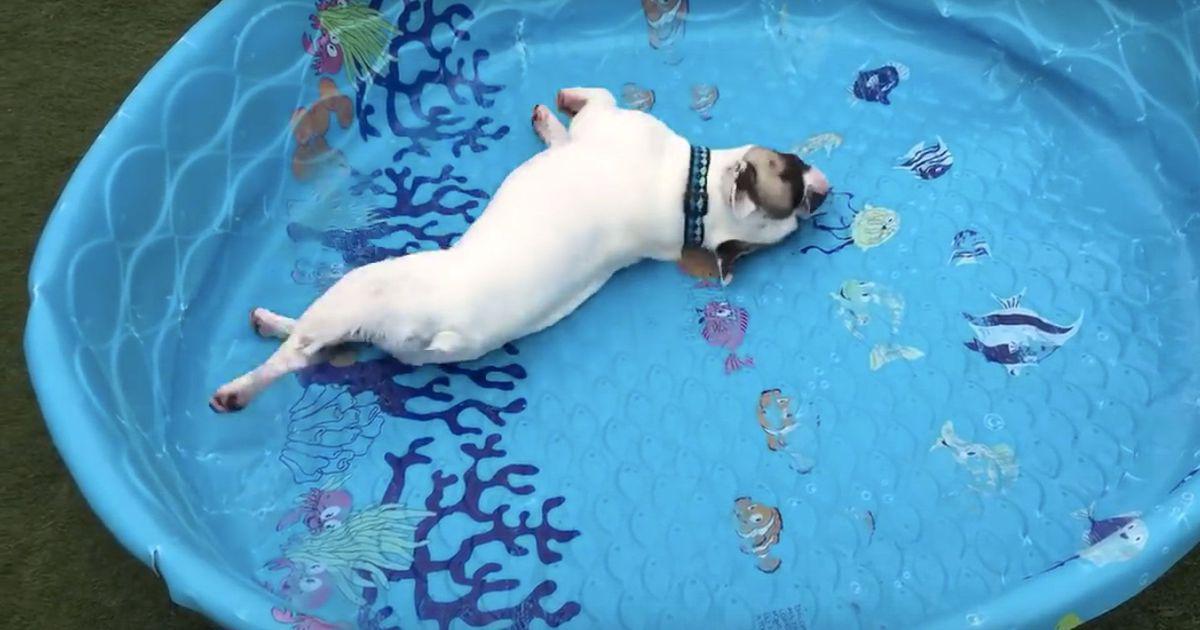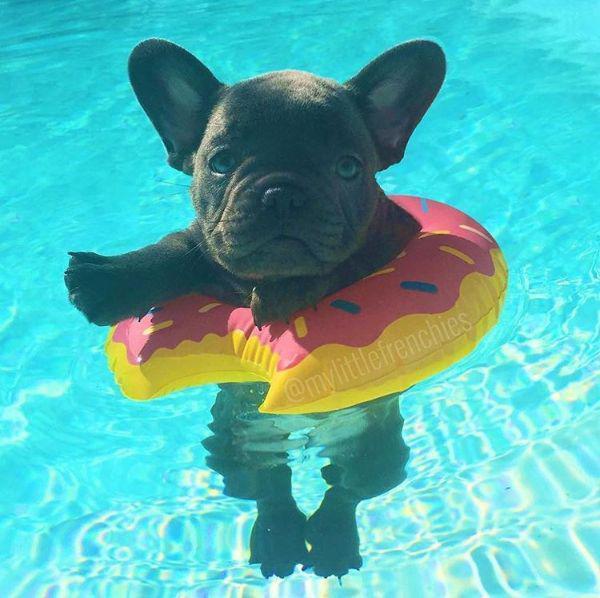The first image is the image on the left, the second image is the image on the right. Analyze the images presented: Is the assertion "There is a black dog floating in an inner tube in a swimming pool" valid? Answer yes or no. Yes. The first image is the image on the left, the second image is the image on the right. Assess this claim about the two images: "there are dogs floating in the pool on inflatable intertubes". Correct or not? Answer yes or no. Yes. 